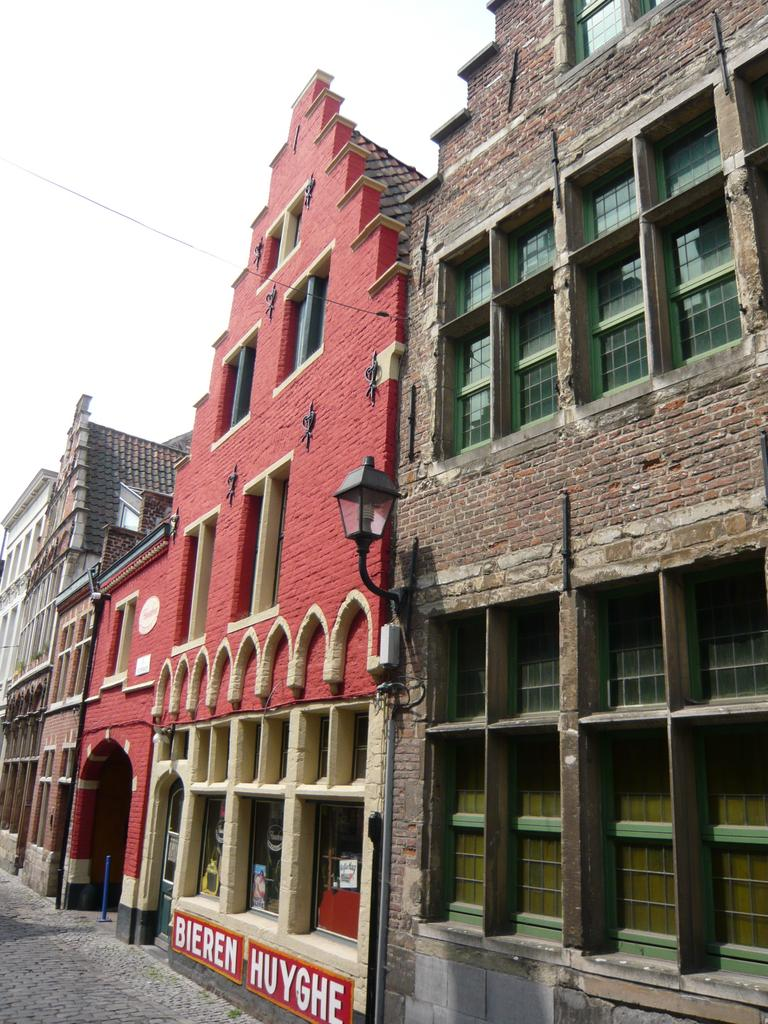What type of structures can be seen in the image? There are buildings in the image. What colors are the buildings? The buildings have brown, red, and cream colors. What type of lighting is present in the image? There are street lights in the image. What can be seen in the background of the image? The sky is visible in the background of the image. Can you see any friends enjoying milk by the sea in the image? There is no reference to friends, milk, or the sea in the image. The image features buildings, street lights, and a visible sky. 